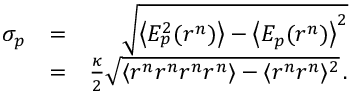Convert formula to latex. <formula><loc_0><loc_0><loc_500><loc_500>\begin{array} { r l r } { \sigma _ { p } } & { = } & { \sqrt { \left \langle E _ { p } ^ { 2 } ( r ^ { n } ) \right \rangle - \left \langle E _ { p } ( r ^ { n } ) \right \rangle ^ { 2 } } } \\ & { = } & { \frac { \kappa } { 2 } \sqrt { \langle r ^ { n } r ^ { n } r ^ { n } r ^ { n } \rangle - \langle r ^ { n } r ^ { n } \rangle ^ { 2 } } \, . } \end{array}</formula> 